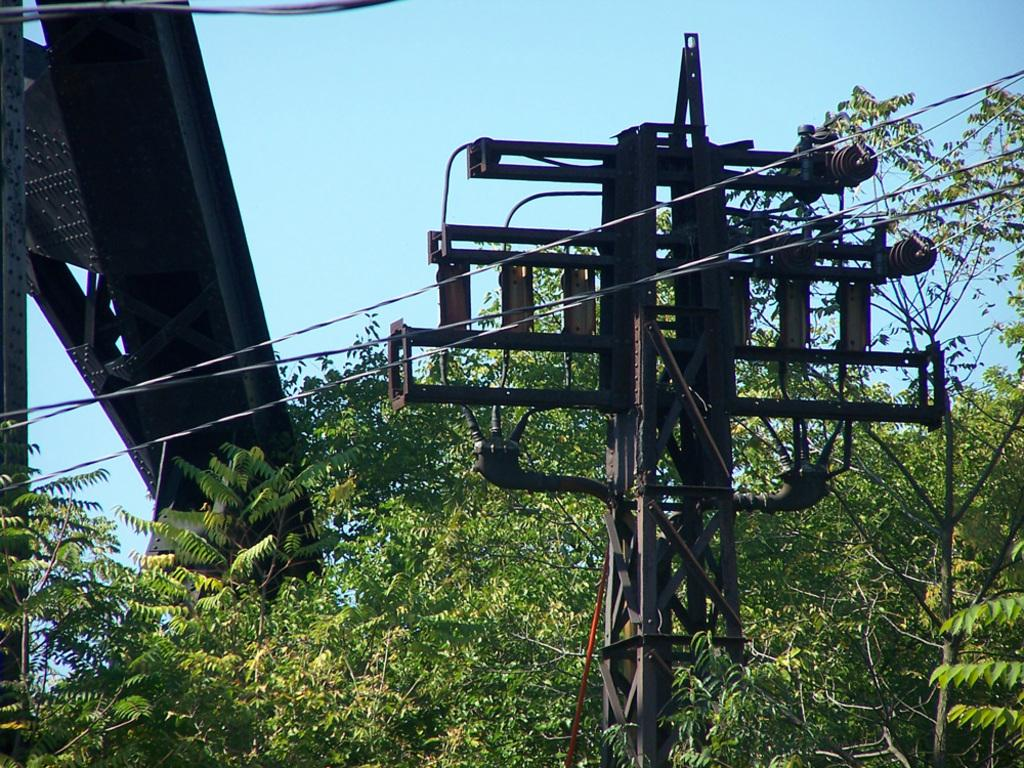What is the primary feature of the image? There are many trees in the image. What can be seen in the middle of the image? There is a pole with wires in the middle of the image. What is located on the left side of the image? There are metal rods on the left side of the image. What color is the ball that is being used as a shade in the image? There is no ball or shade present in the image; it features trees, a pole with wires, and metal rods. Can you hear the thunder in the image? There is no mention of thunder or any sound in the image; it is a still image. 